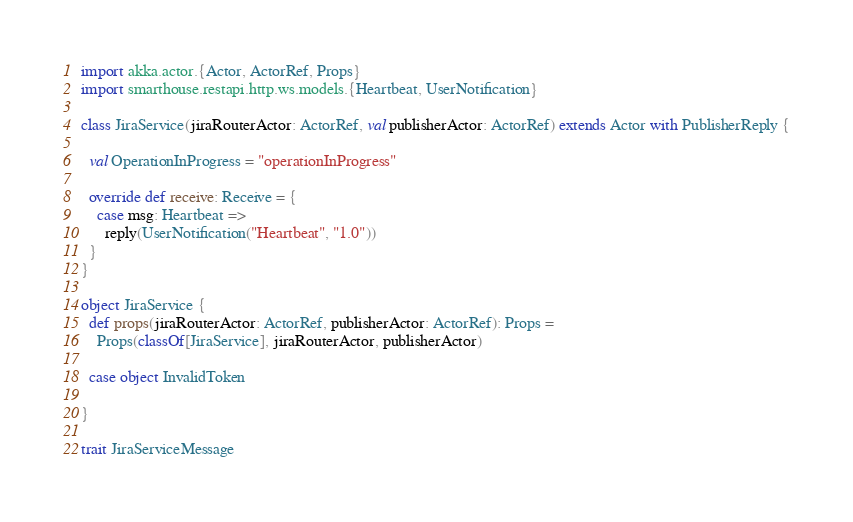<code> <loc_0><loc_0><loc_500><loc_500><_Scala_>
import akka.actor.{Actor, ActorRef, Props}
import smarthouse.restapi.http.ws.models.{Heartbeat, UserNotification}

class JiraService(jiraRouterActor: ActorRef, val publisherActor: ActorRef) extends Actor with PublisherReply {

  val OperationInProgress = "operationInProgress"

  override def receive: Receive = {
    case msg: Heartbeat =>
      reply(UserNotification("Heartbeat", "1.0"))
  }
}

object JiraService {
  def props(jiraRouterActor: ActorRef, publisherActor: ActorRef): Props =
    Props(classOf[JiraService], jiraRouterActor, publisherActor)

  case object InvalidToken

}

trait JiraServiceMessage</code> 